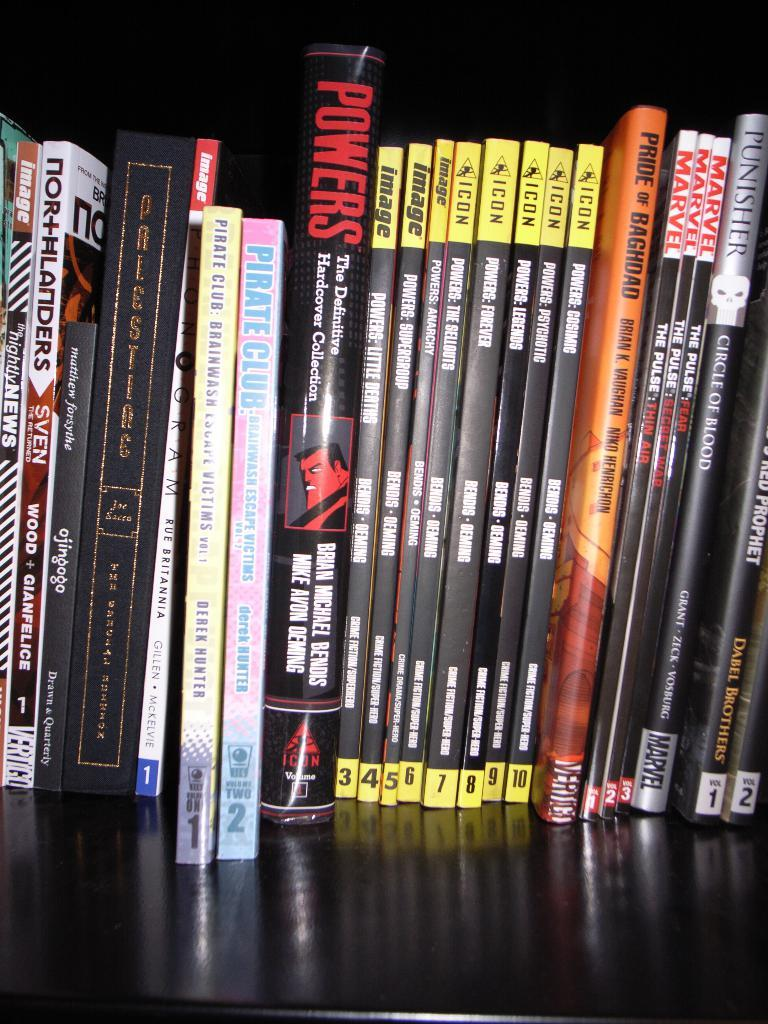<image>
Provide a brief description of the given image. Various books standing on a booksehlf including some about power. 